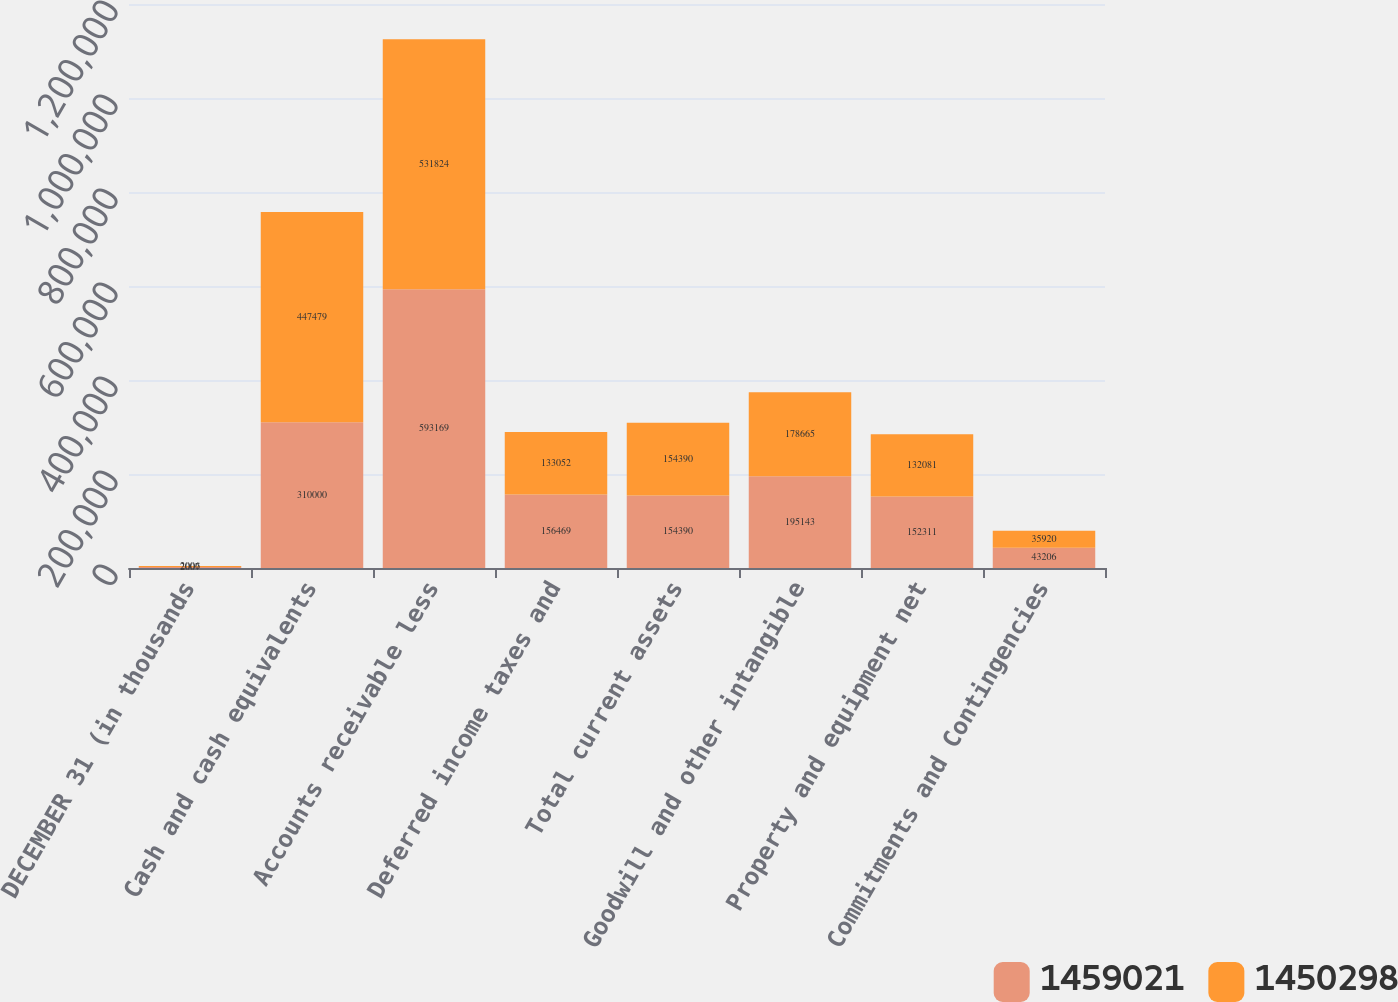<chart> <loc_0><loc_0><loc_500><loc_500><stacked_bar_chart><ecel><fcel>DECEMBER 31 (in thousands<fcel>Cash and cash equivalents<fcel>Accounts receivable less<fcel>Deferred income taxes and<fcel>Total current assets<fcel>Goodwill and other intangible<fcel>Property and equipment net<fcel>Commitments and Contingencies<nl><fcel>1.45902e+06<fcel>2007<fcel>310000<fcel>593169<fcel>156469<fcel>154390<fcel>195143<fcel>152311<fcel>43206<nl><fcel>1.4503e+06<fcel>2006<fcel>447479<fcel>531824<fcel>133052<fcel>154390<fcel>178665<fcel>132081<fcel>35920<nl></chart> 